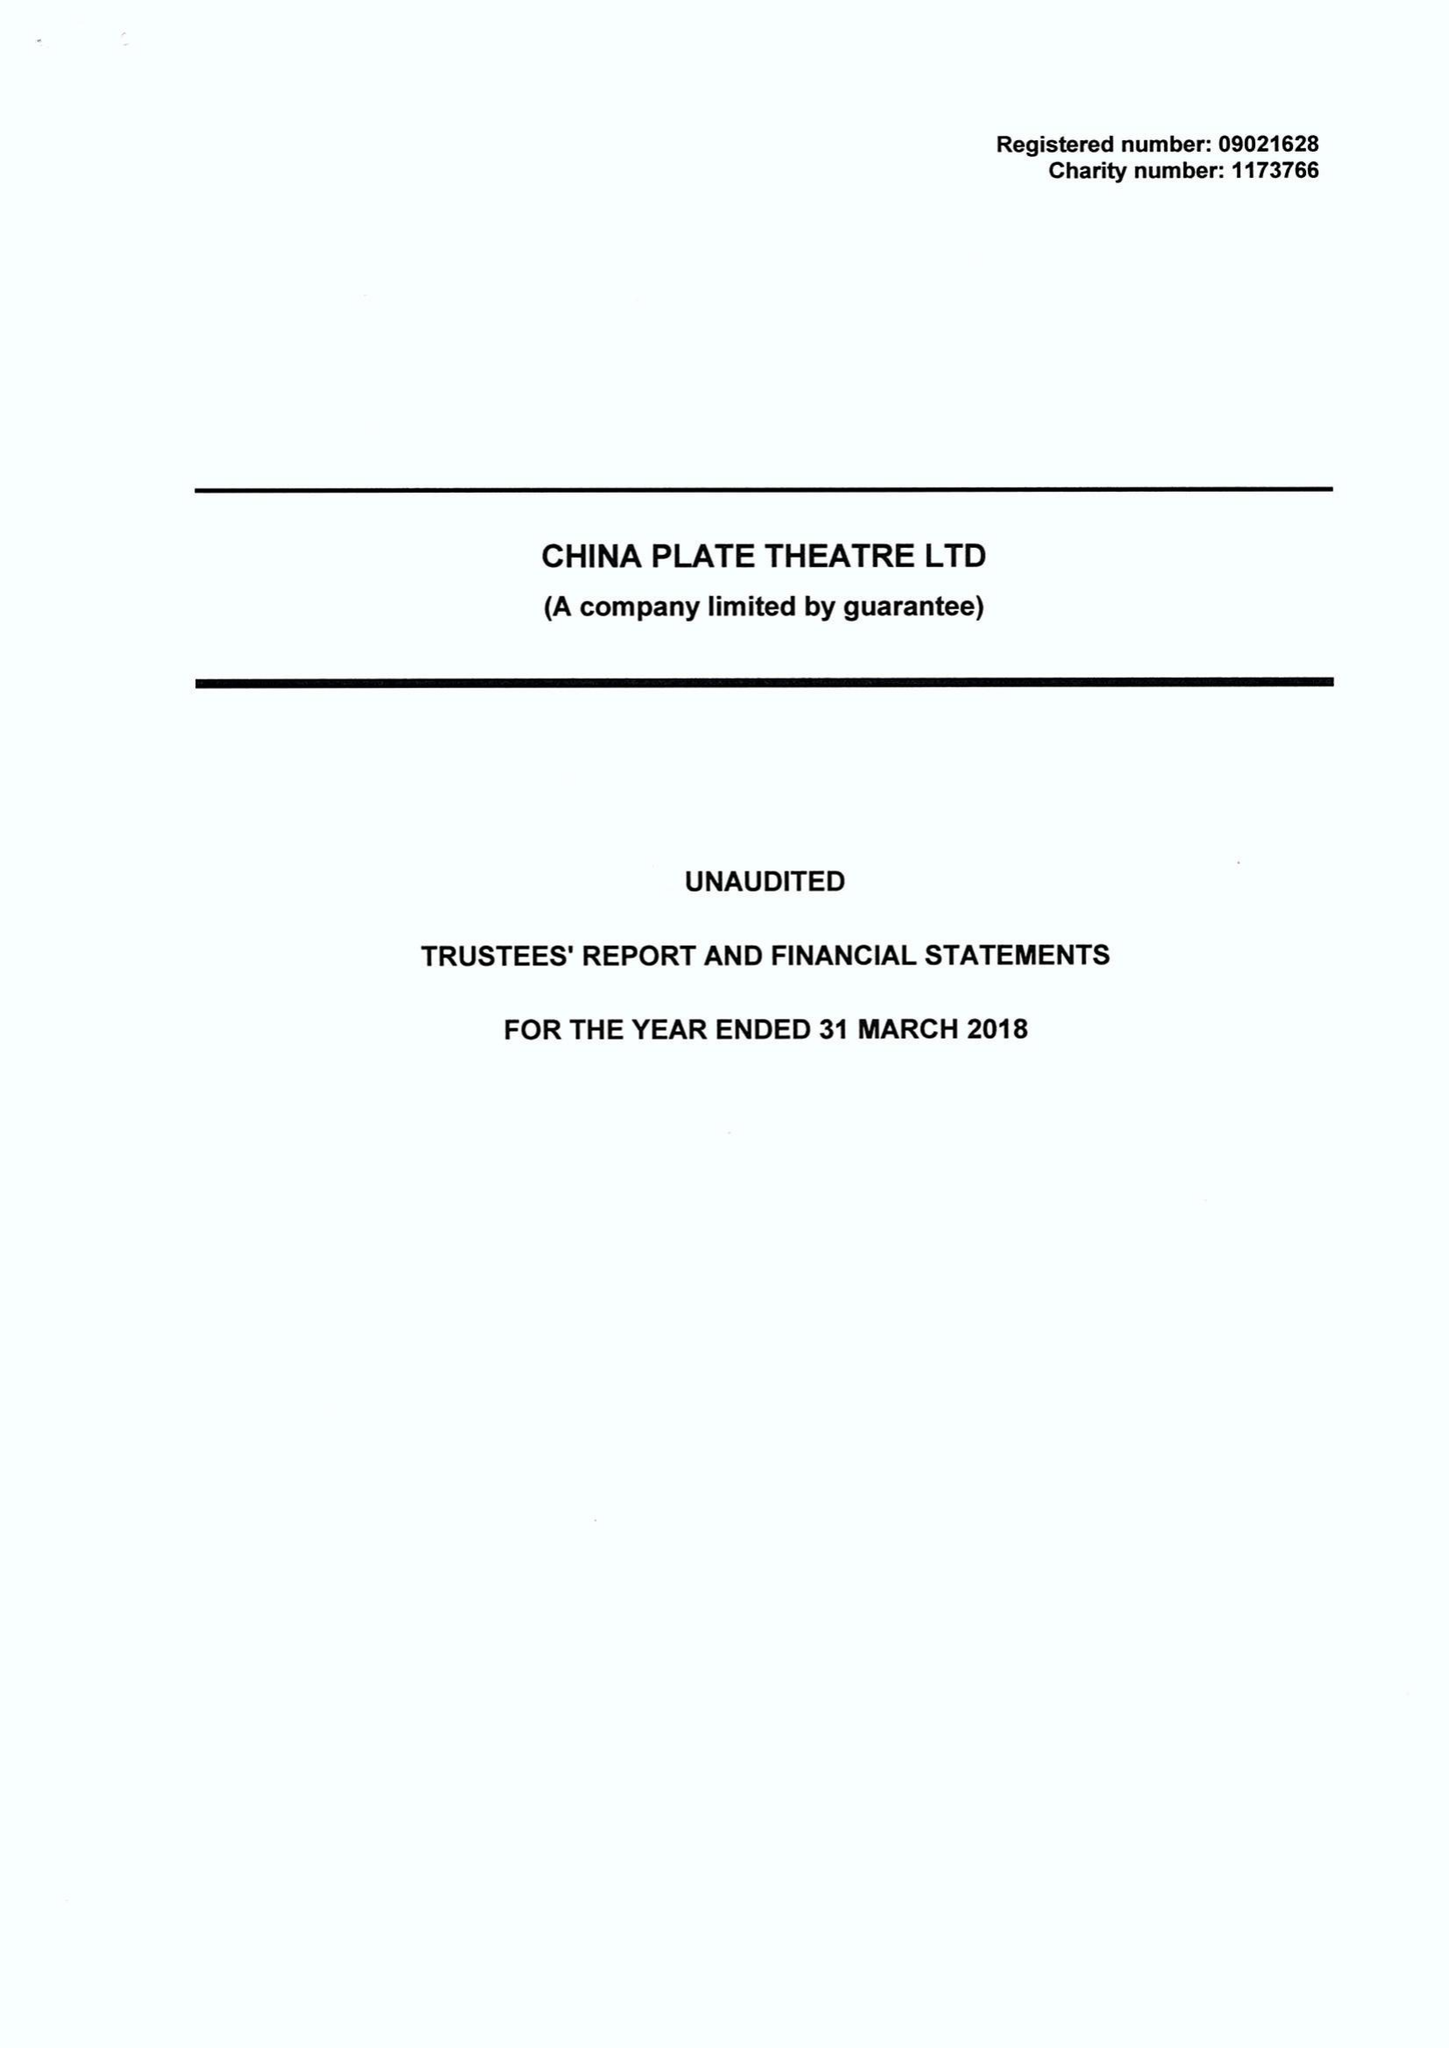What is the value for the charity_name?
Answer the question using a single word or phrase. China Plate Theatre Ltd. 